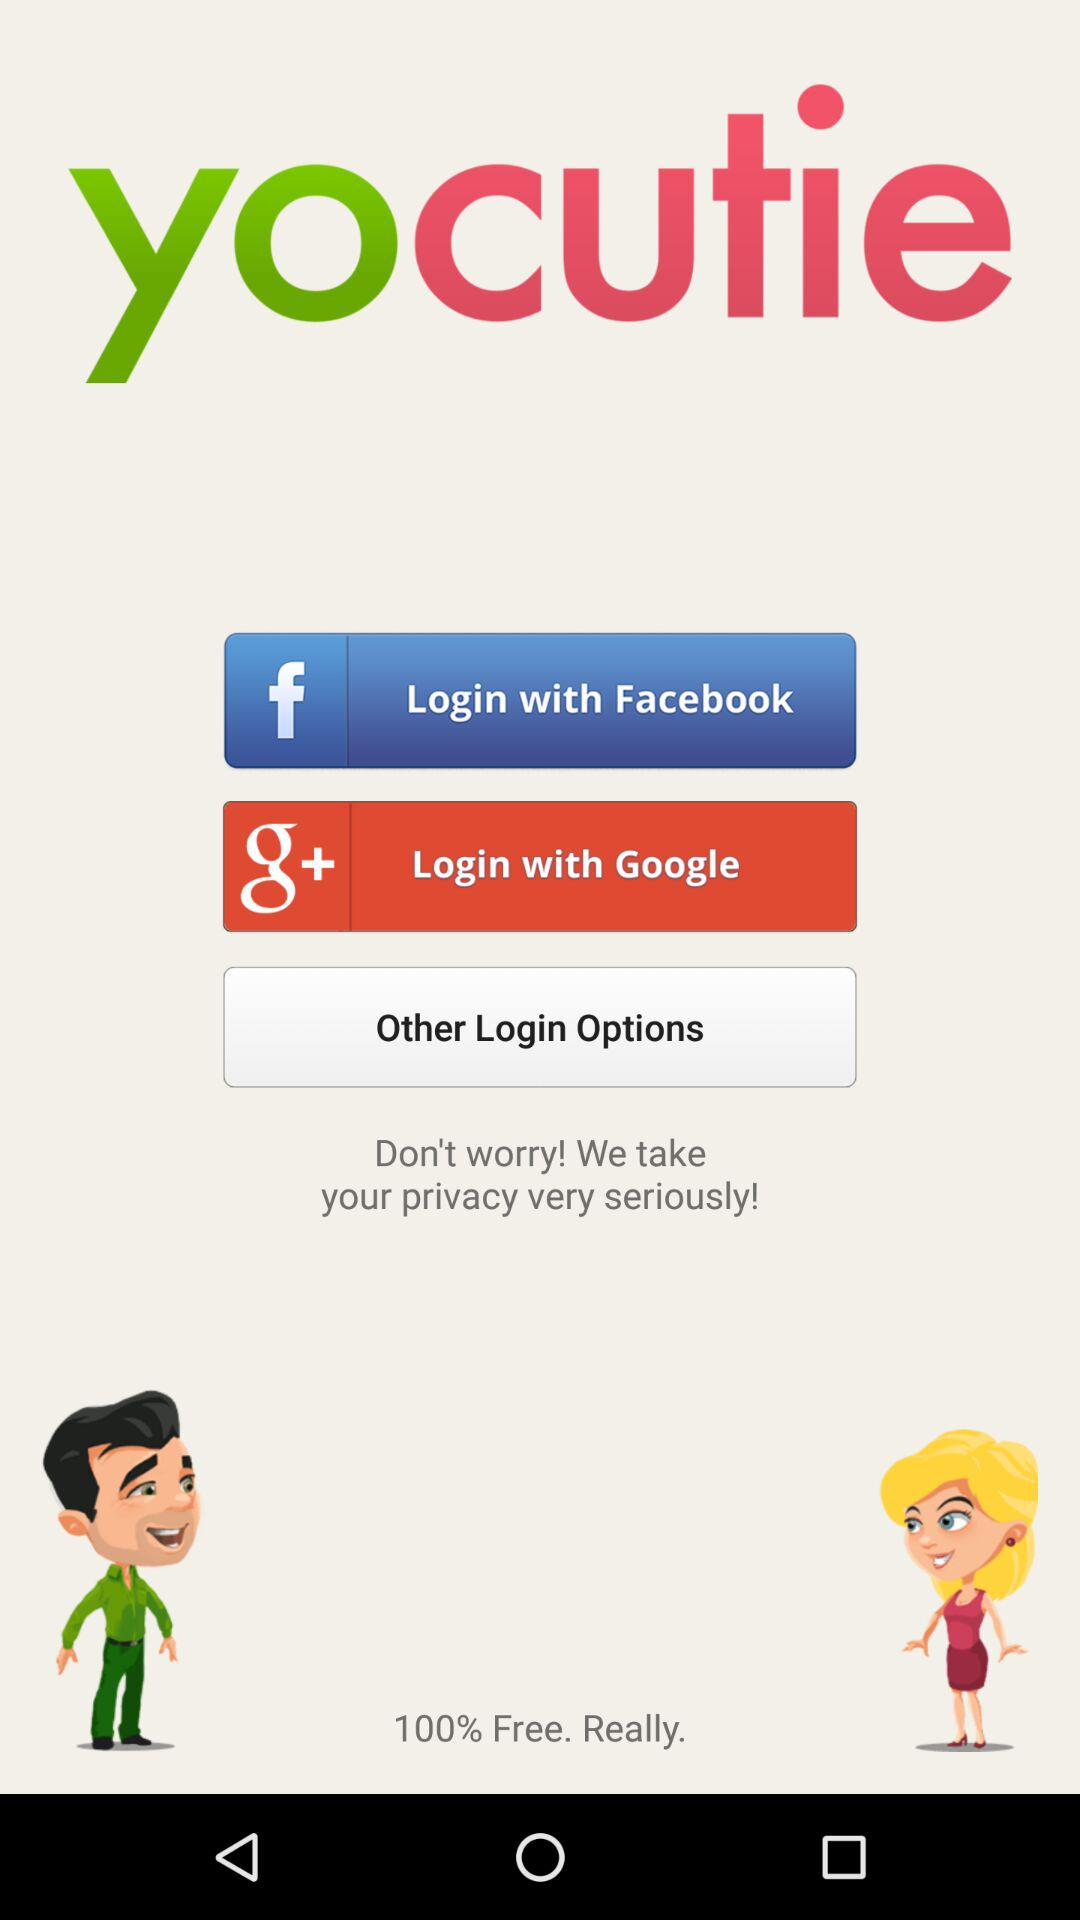What is the application name? The application name is "yocutie". 